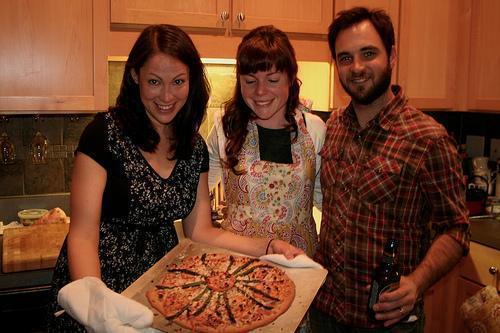How are the people feeling while holding the food?
Indicate the correct response by choosing from the four available options to answer the question.
Options: Sad, angry, scared, proud. Proud. 